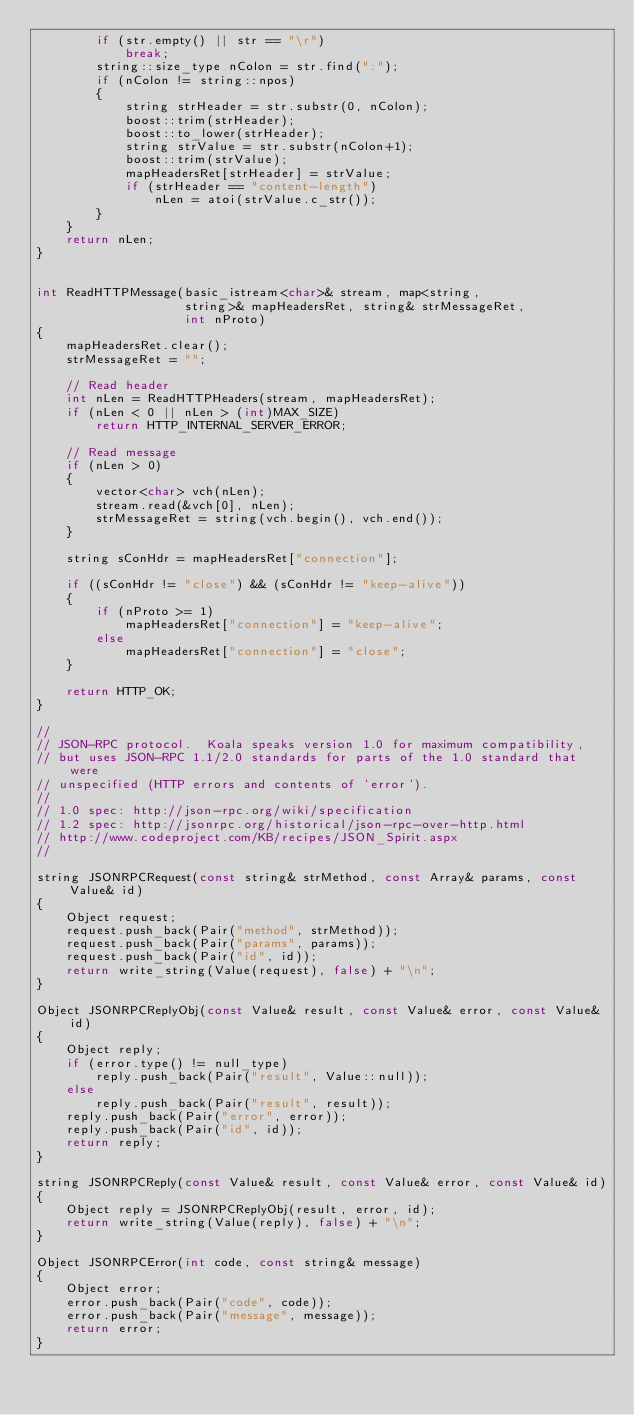<code> <loc_0><loc_0><loc_500><loc_500><_C++_>        if (str.empty() || str == "\r")
            break;
        string::size_type nColon = str.find(":");
        if (nColon != string::npos)
        {
            string strHeader = str.substr(0, nColon);
            boost::trim(strHeader);
            boost::to_lower(strHeader);
            string strValue = str.substr(nColon+1);
            boost::trim(strValue);
            mapHeadersRet[strHeader] = strValue;
            if (strHeader == "content-length")
                nLen = atoi(strValue.c_str());
        }
    }
    return nLen;
}


int ReadHTTPMessage(basic_istream<char>& stream, map<string,
                    string>& mapHeadersRet, string& strMessageRet,
                    int nProto)
{
    mapHeadersRet.clear();
    strMessageRet = "";

    // Read header
    int nLen = ReadHTTPHeaders(stream, mapHeadersRet);
    if (nLen < 0 || nLen > (int)MAX_SIZE)
        return HTTP_INTERNAL_SERVER_ERROR;

    // Read message
    if (nLen > 0)
    {
        vector<char> vch(nLen);
        stream.read(&vch[0], nLen);
        strMessageRet = string(vch.begin(), vch.end());
    }

    string sConHdr = mapHeadersRet["connection"];

    if ((sConHdr != "close") && (sConHdr != "keep-alive"))
    {
        if (nProto >= 1)
            mapHeadersRet["connection"] = "keep-alive";
        else
            mapHeadersRet["connection"] = "close";
    }

    return HTTP_OK;
}

//
// JSON-RPC protocol.  Koala speaks version 1.0 for maximum compatibility,
// but uses JSON-RPC 1.1/2.0 standards for parts of the 1.0 standard that were
// unspecified (HTTP errors and contents of 'error').
//
// 1.0 spec: http://json-rpc.org/wiki/specification
// 1.2 spec: http://jsonrpc.org/historical/json-rpc-over-http.html
// http://www.codeproject.com/KB/recipes/JSON_Spirit.aspx
//

string JSONRPCRequest(const string& strMethod, const Array& params, const Value& id)
{
    Object request;
    request.push_back(Pair("method", strMethod));
    request.push_back(Pair("params", params));
    request.push_back(Pair("id", id));
    return write_string(Value(request), false) + "\n";
}

Object JSONRPCReplyObj(const Value& result, const Value& error, const Value& id)
{
    Object reply;
    if (error.type() != null_type)
        reply.push_back(Pair("result", Value::null));
    else
        reply.push_back(Pair("result", result));
    reply.push_back(Pair("error", error));
    reply.push_back(Pair("id", id));
    return reply;
}

string JSONRPCReply(const Value& result, const Value& error, const Value& id)
{
    Object reply = JSONRPCReplyObj(result, error, id);
    return write_string(Value(reply), false) + "\n";
}

Object JSONRPCError(int code, const string& message)
{
    Object error;
    error.push_back(Pair("code", code));
    error.push_back(Pair("message", message));
    return error;
}
</code> 